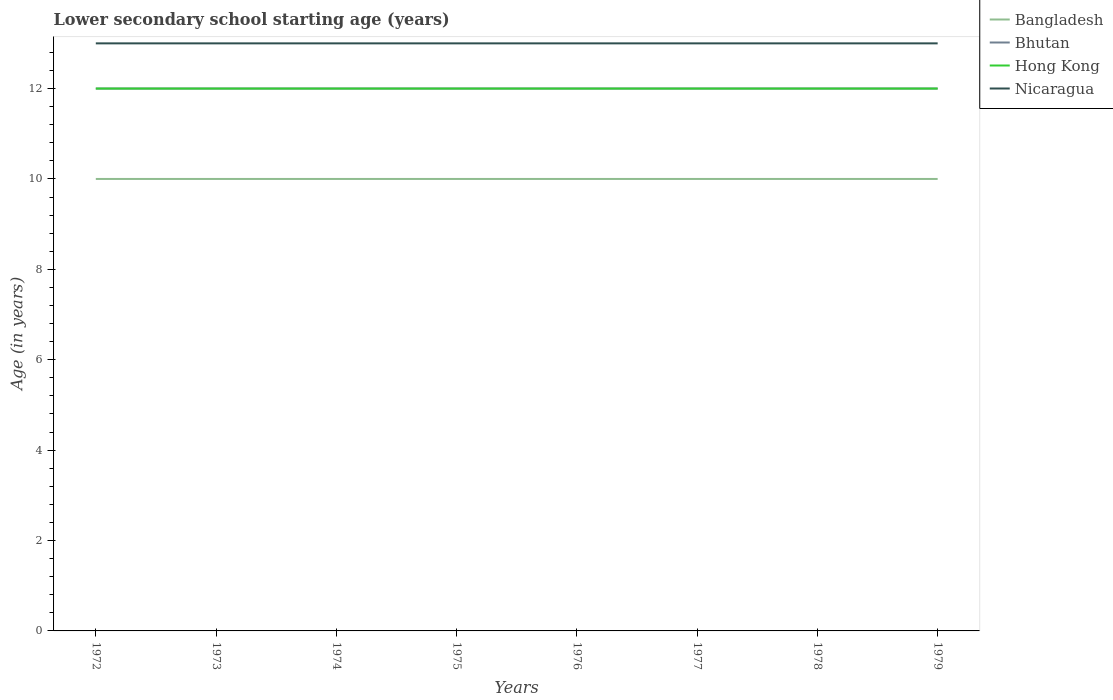How many different coloured lines are there?
Offer a terse response. 4. Across all years, what is the maximum lower secondary school starting age of children in Bhutan?
Keep it short and to the point. 12. What is the difference between the highest and the second highest lower secondary school starting age of children in Bangladesh?
Make the answer very short. 0. Is the lower secondary school starting age of children in Bhutan strictly greater than the lower secondary school starting age of children in Nicaragua over the years?
Offer a very short reply. Yes. How many lines are there?
Make the answer very short. 4. What is the difference between two consecutive major ticks on the Y-axis?
Ensure brevity in your answer.  2. Are the values on the major ticks of Y-axis written in scientific E-notation?
Provide a short and direct response. No. Does the graph contain grids?
Keep it short and to the point. No. Where does the legend appear in the graph?
Offer a very short reply. Top right. How many legend labels are there?
Offer a terse response. 4. What is the title of the graph?
Your answer should be very brief. Lower secondary school starting age (years). What is the label or title of the X-axis?
Offer a terse response. Years. What is the label or title of the Y-axis?
Your answer should be very brief. Age (in years). What is the Age (in years) in Bangladesh in 1972?
Your answer should be compact. 10. What is the Age (in years) of Bhutan in 1972?
Make the answer very short. 12. What is the Age (in years) in Hong Kong in 1972?
Provide a succinct answer. 12. What is the Age (in years) of Nicaragua in 1972?
Your response must be concise. 13. What is the Age (in years) in Bangladesh in 1973?
Your response must be concise. 10. What is the Age (in years) in Bhutan in 1973?
Make the answer very short. 12. What is the Age (in years) of Nicaragua in 1973?
Your answer should be compact. 13. What is the Age (in years) in Bangladesh in 1975?
Your answer should be compact. 10. What is the Age (in years) of Bangladesh in 1976?
Your response must be concise. 10. What is the Age (in years) of Bhutan in 1976?
Give a very brief answer. 12. What is the Age (in years) in Nicaragua in 1976?
Ensure brevity in your answer.  13. What is the Age (in years) in Hong Kong in 1977?
Your response must be concise. 12. What is the Age (in years) of Bangladesh in 1978?
Make the answer very short. 10. What is the Age (in years) of Bhutan in 1978?
Ensure brevity in your answer.  12. What is the Age (in years) of Hong Kong in 1978?
Give a very brief answer. 12. What is the Age (in years) of Bangladesh in 1979?
Keep it short and to the point. 10. What is the Age (in years) of Bhutan in 1979?
Offer a very short reply. 12. Across all years, what is the maximum Age (in years) of Bhutan?
Ensure brevity in your answer.  12. Across all years, what is the minimum Age (in years) of Bangladesh?
Your response must be concise. 10. Across all years, what is the minimum Age (in years) in Hong Kong?
Make the answer very short. 12. What is the total Age (in years) in Bangladesh in the graph?
Your answer should be compact. 80. What is the total Age (in years) in Bhutan in the graph?
Ensure brevity in your answer.  96. What is the total Age (in years) of Hong Kong in the graph?
Provide a succinct answer. 96. What is the total Age (in years) of Nicaragua in the graph?
Keep it short and to the point. 104. What is the difference between the Age (in years) in Bangladesh in 1972 and that in 1973?
Your response must be concise. 0. What is the difference between the Age (in years) in Bhutan in 1972 and that in 1973?
Offer a terse response. 0. What is the difference between the Age (in years) in Bangladesh in 1972 and that in 1974?
Keep it short and to the point. 0. What is the difference between the Age (in years) of Nicaragua in 1972 and that in 1974?
Provide a succinct answer. 0. What is the difference between the Age (in years) of Bangladesh in 1972 and that in 1975?
Keep it short and to the point. 0. What is the difference between the Age (in years) in Hong Kong in 1972 and that in 1975?
Make the answer very short. 0. What is the difference between the Age (in years) in Nicaragua in 1972 and that in 1975?
Keep it short and to the point. 0. What is the difference between the Age (in years) in Bangladesh in 1972 and that in 1976?
Make the answer very short. 0. What is the difference between the Age (in years) of Bhutan in 1972 and that in 1976?
Give a very brief answer. 0. What is the difference between the Age (in years) in Nicaragua in 1972 and that in 1976?
Provide a succinct answer. 0. What is the difference between the Age (in years) of Hong Kong in 1972 and that in 1977?
Offer a very short reply. 0. What is the difference between the Age (in years) of Nicaragua in 1972 and that in 1977?
Your answer should be very brief. 0. What is the difference between the Age (in years) in Bangladesh in 1972 and that in 1978?
Offer a very short reply. 0. What is the difference between the Age (in years) in Bhutan in 1972 and that in 1978?
Your response must be concise. 0. What is the difference between the Age (in years) of Hong Kong in 1972 and that in 1978?
Your answer should be compact. 0. What is the difference between the Age (in years) in Nicaragua in 1972 and that in 1978?
Your response must be concise. 0. What is the difference between the Age (in years) of Hong Kong in 1972 and that in 1979?
Your response must be concise. 0. What is the difference between the Age (in years) in Nicaragua in 1972 and that in 1979?
Keep it short and to the point. 0. What is the difference between the Age (in years) of Bhutan in 1973 and that in 1974?
Offer a very short reply. 0. What is the difference between the Age (in years) in Hong Kong in 1973 and that in 1974?
Your answer should be very brief. 0. What is the difference between the Age (in years) of Bhutan in 1973 and that in 1975?
Make the answer very short. 0. What is the difference between the Age (in years) in Bhutan in 1973 and that in 1976?
Offer a very short reply. 0. What is the difference between the Age (in years) of Hong Kong in 1973 and that in 1976?
Keep it short and to the point. 0. What is the difference between the Age (in years) in Nicaragua in 1973 and that in 1976?
Your response must be concise. 0. What is the difference between the Age (in years) of Bhutan in 1973 and that in 1977?
Provide a short and direct response. 0. What is the difference between the Age (in years) of Hong Kong in 1973 and that in 1977?
Offer a terse response. 0. What is the difference between the Age (in years) of Nicaragua in 1973 and that in 1977?
Offer a very short reply. 0. What is the difference between the Age (in years) of Nicaragua in 1973 and that in 1978?
Your response must be concise. 0. What is the difference between the Age (in years) of Bangladesh in 1973 and that in 1979?
Make the answer very short. 0. What is the difference between the Age (in years) of Bhutan in 1974 and that in 1975?
Keep it short and to the point. 0. What is the difference between the Age (in years) of Hong Kong in 1974 and that in 1976?
Your answer should be compact. 0. What is the difference between the Age (in years) in Bangladesh in 1974 and that in 1977?
Offer a terse response. 0. What is the difference between the Age (in years) of Bhutan in 1974 and that in 1977?
Your response must be concise. 0. What is the difference between the Age (in years) in Hong Kong in 1974 and that in 1977?
Give a very brief answer. 0. What is the difference between the Age (in years) of Bangladesh in 1974 and that in 1978?
Your response must be concise. 0. What is the difference between the Age (in years) of Bhutan in 1974 and that in 1978?
Offer a very short reply. 0. What is the difference between the Age (in years) in Hong Kong in 1974 and that in 1978?
Make the answer very short. 0. What is the difference between the Age (in years) in Bangladesh in 1974 and that in 1979?
Give a very brief answer. 0. What is the difference between the Age (in years) of Bhutan in 1974 and that in 1979?
Offer a terse response. 0. What is the difference between the Age (in years) of Hong Kong in 1974 and that in 1979?
Keep it short and to the point. 0. What is the difference between the Age (in years) of Bangladesh in 1975 and that in 1976?
Your response must be concise. 0. What is the difference between the Age (in years) of Nicaragua in 1975 and that in 1976?
Your response must be concise. 0. What is the difference between the Age (in years) in Bangladesh in 1975 and that in 1977?
Give a very brief answer. 0. What is the difference between the Age (in years) in Bhutan in 1975 and that in 1977?
Provide a succinct answer. 0. What is the difference between the Age (in years) of Hong Kong in 1975 and that in 1977?
Offer a very short reply. 0. What is the difference between the Age (in years) in Nicaragua in 1975 and that in 1977?
Keep it short and to the point. 0. What is the difference between the Age (in years) in Bangladesh in 1975 and that in 1978?
Provide a succinct answer. 0. What is the difference between the Age (in years) in Hong Kong in 1975 and that in 1978?
Give a very brief answer. 0. What is the difference between the Age (in years) of Bangladesh in 1975 and that in 1979?
Give a very brief answer. 0. What is the difference between the Age (in years) of Hong Kong in 1975 and that in 1979?
Your answer should be compact. 0. What is the difference between the Age (in years) in Nicaragua in 1975 and that in 1979?
Your response must be concise. 0. What is the difference between the Age (in years) in Bangladesh in 1976 and that in 1977?
Offer a terse response. 0. What is the difference between the Age (in years) in Bhutan in 1976 and that in 1977?
Ensure brevity in your answer.  0. What is the difference between the Age (in years) in Hong Kong in 1976 and that in 1977?
Provide a succinct answer. 0. What is the difference between the Age (in years) of Bangladesh in 1976 and that in 1978?
Give a very brief answer. 0. What is the difference between the Age (in years) in Bhutan in 1976 and that in 1978?
Your response must be concise. 0. What is the difference between the Age (in years) of Hong Kong in 1976 and that in 1978?
Provide a short and direct response. 0. What is the difference between the Age (in years) of Bangladesh in 1976 and that in 1979?
Make the answer very short. 0. What is the difference between the Age (in years) in Hong Kong in 1976 and that in 1979?
Keep it short and to the point. 0. What is the difference between the Age (in years) of Bhutan in 1977 and that in 1978?
Give a very brief answer. 0. What is the difference between the Age (in years) of Nicaragua in 1977 and that in 1978?
Provide a short and direct response. 0. What is the difference between the Age (in years) of Bangladesh in 1977 and that in 1979?
Make the answer very short. 0. What is the difference between the Age (in years) of Bhutan in 1977 and that in 1979?
Provide a succinct answer. 0. What is the difference between the Age (in years) of Bhutan in 1978 and that in 1979?
Your answer should be very brief. 0. What is the difference between the Age (in years) in Hong Kong in 1978 and that in 1979?
Your answer should be compact. 0. What is the difference between the Age (in years) of Bangladesh in 1972 and the Age (in years) of Bhutan in 1973?
Your answer should be compact. -2. What is the difference between the Age (in years) of Bhutan in 1972 and the Age (in years) of Hong Kong in 1973?
Your answer should be very brief. 0. What is the difference between the Age (in years) in Bhutan in 1972 and the Age (in years) in Nicaragua in 1973?
Give a very brief answer. -1. What is the difference between the Age (in years) in Hong Kong in 1972 and the Age (in years) in Nicaragua in 1973?
Provide a short and direct response. -1. What is the difference between the Age (in years) of Bhutan in 1972 and the Age (in years) of Hong Kong in 1974?
Your answer should be very brief. 0. What is the difference between the Age (in years) of Bhutan in 1972 and the Age (in years) of Nicaragua in 1974?
Keep it short and to the point. -1. What is the difference between the Age (in years) of Hong Kong in 1972 and the Age (in years) of Nicaragua in 1974?
Your answer should be very brief. -1. What is the difference between the Age (in years) in Bangladesh in 1972 and the Age (in years) in Hong Kong in 1975?
Provide a short and direct response. -2. What is the difference between the Age (in years) of Bangladesh in 1972 and the Age (in years) of Nicaragua in 1975?
Make the answer very short. -3. What is the difference between the Age (in years) of Bhutan in 1972 and the Age (in years) of Hong Kong in 1975?
Offer a terse response. 0. What is the difference between the Age (in years) of Hong Kong in 1972 and the Age (in years) of Nicaragua in 1975?
Your answer should be very brief. -1. What is the difference between the Age (in years) in Bangladesh in 1972 and the Age (in years) in Bhutan in 1976?
Ensure brevity in your answer.  -2. What is the difference between the Age (in years) in Bhutan in 1972 and the Age (in years) in Hong Kong in 1976?
Offer a very short reply. 0. What is the difference between the Age (in years) in Bhutan in 1972 and the Age (in years) in Nicaragua in 1976?
Offer a terse response. -1. What is the difference between the Age (in years) in Hong Kong in 1972 and the Age (in years) in Nicaragua in 1976?
Your response must be concise. -1. What is the difference between the Age (in years) of Bangladesh in 1972 and the Age (in years) of Bhutan in 1977?
Provide a succinct answer. -2. What is the difference between the Age (in years) of Bangladesh in 1972 and the Age (in years) of Hong Kong in 1977?
Your answer should be very brief. -2. What is the difference between the Age (in years) of Bangladesh in 1972 and the Age (in years) of Nicaragua in 1977?
Give a very brief answer. -3. What is the difference between the Age (in years) of Bhutan in 1972 and the Age (in years) of Nicaragua in 1977?
Make the answer very short. -1. What is the difference between the Age (in years) in Hong Kong in 1972 and the Age (in years) in Nicaragua in 1977?
Make the answer very short. -1. What is the difference between the Age (in years) of Bangladesh in 1972 and the Age (in years) of Hong Kong in 1978?
Offer a terse response. -2. What is the difference between the Age (in years) of Bhutan in 1972 and the Age (in years) of Nicaragua in 1978?
Provide a succinct answer. -1. What is the difference between the Age (in years) of Bhutan in 1972 and the Age (in years) of Nicaragua in 1979?
Your answer should be compact. -1. What is the difference between the Age (in years) in Hong Kong in 1972 and the Age (in years) in Nicaragua in 1979?
Provide a short and direct response. -1. What is the difference between the Age (in years) in Bangladesh in 1973 and the Age (in years) in Bhutan in 1974?
Your answer should be very brief. -2. What is the difference between the Age (in years) in Bangladesh in 1973 and the Age (in years) in Nicaragua in 1974?
Your answer should be very brief. -3. What is the difference between the Age (in years) of Bangladesh in 1973 and the Age (in years) of Hong Kong in 1975?
Offer a terse response. -2. What is the difference between the Age (in years) of Bangladesh in 1973 and the Age (in years) of Nicaragua in 1975?
Your response must be concise. -3. What is the difference between the Age (in years) in Bangladesh in 1973 and the Age (in years) in Bhutan in 1976?
Offer a very short reply. -2. What is the difference between the Age (in years) in Bhutan in 1973 and the Age (in years) in Nicaragua in 1976?
Keep it short and to the point. -1. What is the difference between the Age (in years) of Hong Kong in 1973 and the Age (in years) of Nicaragua in 1976?
Your answer should be very brief. -1. What is the difference between the Age (in years) of Bangladesh in 1973 and the Age (in years) of Hong Kong in 1977?
Your response must be concise. -2. What is the difference between the Age (in years) of Bangladesh in 1973 and the Age (in years) of Nicaragua in 1977?
Your answer should be compact. -3. What is the difference between the Age (in years) in Bhutan in 1973 and the Age (in years) in Nicaragua in 1977?
Offer a very short reply. -1. What is the difference between the Age (in years) of Hong Kong in 1973 and the Age (in years) of Nicaragua in 1977?
Provide a short and direct response. -1. What is the difference between the Age (in years) in Bangladesh in 1973 and the Age (in years) in Bhutan in 1978?
Ensure brevity in your answer.  -2. What is the difference between the Age (in years) in Bangladesh in 1973 and the Age (in years) in Hong Kong in 1978?
Offer a terse response. -2. What is the difference between the Age (in years) in Bangladesh in 1973 and the Age (in years) in Nicaragua in 1978?
Provide a succinct answer. -3. What is the difference between the Age (in years) of Bhutan in 1973 and the Age (in years) of Nicaragua in 1978?
Provide a short and direct response. -1. What is the difference between the Age (in years) of Bangladesh in 1973 and the Age (in years) of Hong Kong in 1979?
Keep it short and to the point. -2. What is the difference between the Age (in years) of Bhutan in 1973 and the Age (in years) of Nicaragua in 1979?
Make the answer very short. -1. What is the difference between the Age (in years) in Hong Kong in 1973 and the Age (in years) in Nicaragua in 1979?
Keep it short and to the point. -1. What is the difference between the Age (in years) in Bangladesh in 1974 and the Age (in years) in Bhutan in 1975?
Your answer should be very brief. -2. What is the difference between the Age (in years) in Bhutan in 1974 and the Age (in years) in Nicaragua in 1975?
Your response must be concise. -1. What is the difference between the Age (in years) of Bangladesh in 1974 and the Age (in years) of Bhutan in 1976?
Offer a very short reply. -2. What is the difference between the Age (in years) in Bangladesh in 1974 and the Age (in years) in Nicaragua in 1976?
Ensure brevity in your answer.  -3. What is the difference between the Age (in years) in Bhutan in 1974 and the Age (in years) in Hong Kong in 1976?
Offer a very short reply. 0. What is the difference between the Age (in years) in Bhutan in 1974 and the Age (in years) in Nicaragua in 1976?
Your response must be concise. -1. What is the difference between the Age (in years) in Bangladesh in 1974 and the Age (in years) in Bhutan in 1977?
Offer a very short reply. -2. What is the difference between the Age (in years) of Bangladesh in 1974 and the Age (in years) of Hong Kong in 1977?
Your answer should be compact. -2. What is the difference between the Age (in years) in Bhutan in 1974 and the Age (in years) in Hong Kong in 1977?
Provide a succinct answer. 0. What is the difference between the Age (in years) in Bhutan in 1974 and the Age (in years) in Nicaragua in 1977?
Your answer should be compact. -1. What is the difference between the Age (in years) in Hong Kong in 1974 and the Age (in years) in Nicaragua in 1977?
Offer a very short reply. -1. What is the difference between the Age (in years) in Bangladesh in 1974 and the Age (in years) in Hong Kong in 1978?
Give a very brief answer. -2. What is the difference between the Age (in years) in Bhutan in 1974 and the Age (in years) in Nicaragua in 1978?
Your answer should be compact. -1. What is the difference between the Age (in years) of Hong Kong in 1974 and the Age (in years) of Nicaragua in 1978?
Provide a succinct answer. -1. What is the difference between the Age (in years) in Bangladesh in 1974 and the Age (in years) in Hong Kong in 1979?
Your response must be concise. -2. What is the difference between the Age (in years) in Bangladesh in 1974 and the Age (in years) in Nicaragua in 1979?
Your answer should be compact. -3. What is the difference between the Age (in years) of Bhutan in 1974 and the Age (in years) of Nicaragua in 1979?
Give a very brief answer. -1. What is the difference between the Age (in years) in Hong Kong in 1974 and the Age (in years) in Nicaragua in 1979?
Offer a very short reply. -1. What is the difference between the Age (in years) in Bhutan in 1975 and the Age (in years) in Hong Kong in 1976?
Give a very brief answer. 0. What is the difference between the Age (in years) in Bangladesh in 1975 and the Age (in years) in Bhutan in 1977?
Offer a very short reply. -2. What is the difference between the Age (in years) in Bangladesh in 1975 and the Age (in years) in Nicaragua in 1977?
Keep it short and to the point. -3. What is the difference between the Age (in years) in Bhutan in 1975 and the Age (in years) in Hong Kong in 1977?
Give a very brief answer. 0. What is the difference between the Age (in years) in Hong Kong in 1975 and the Age (in years) in Nicaragua in 1978?
Offer a very short reply. -1. What is the difference between the Age (in years) in Bangladesh in 1975 and the Age (in years) in Bhutan in 1979?
Your response must be concise. -2. What is the difference between the Age (in years) in Bhutan in 1975 and the Age (in years) in Hong Kong in 1979?
Offer a very short reply. 0. What is the difference between the Age (in years) in Bhutan in 1975 and the Age (in years) in Nicaragua in 1979?
Ensure brevity in your answer.  -1. What is the difference between the Age (in years) of Hong Kong in 1975 and the Age (in years) of Nicaragua in 1979?
Ensure brevity in your answer.  -1. What is the difference between the Age (in years) in Bangladesh in 1976 and the Age (in years) in Bhutan in 1977?
Give a very brief answer. -2. What is the difference between the Age (in years) of Bangladesh in 1976 and the Age (in years) of Hong Kong in 1977?
Provide a short and direct response. -2. What is the difference between the Age (in years) of Bangladesh in 1976 and the Age (in years) of Nicaragua in 1977?
Your answer should be very brief. -3. What is the difference between the Age (in years) in Bangladesh in 1976 and the Age (in years) in Bhutan in 1978?
Keep it short and to the point. -2. What is the difference between the Age (in years) in Bangladesh in 1976 and the Age (in years) in Hong Kong in 1978?
Offer a very short reply. -2. What is the difference between the Age (in years) in Bangladesh in 1976 and the Age (in years) in Nicaragua in 1978?
Ensure brevity in your answer.  -3. What is the difference between the Age (in years) in Bhutan in 1976 and the Age (in years) in Hong Kong in 1978?
Your answer should be compact. 0. What is the difference between the Age (in years) in Bhutan in 1976 and the Age (in years) in Nicaragua in 1978?
Your response must be concise. -1. What is the difference between the Age (in years) of Bangladesh in 1976 and the Age (in years) of Nicaragua in 1979?
Provide a short and direct response. -3. What is the difference between the Age (in years) in Bangladesh in 1977 and the Age (in years) in Hong Kong in 1978?
Provide a succinct answer. -2. What is the difference between the Age (in years) in Bhutan in 1977 and the Age (in years) in Hong Kong in 1978?
Ensure brevity in your answer.  0. What is the difference between the Age (in years) in Hong Kong in 1977 and the Age (in years) in Nicaragua in 1978?
Offer a very short reply. -1. What is the difference between the Age (in years) of Bangladesh in 1977 and the Age (in years) of Nicaragua in 1979?
Keep it short and to the point. -3. What is the difference between the Age (in years) in Bhutan in 1977 and the Age (in years) in Hong Kong in 1979?
Give a very brief answer. 0. What is the difference between the Age (in years) in Bhutan in 1977 and the Age (in years) in Nicaragua in 1979?
Offer a very short reply. -1. What is the difference between the Age (in years) of Bangladesh in 1978 and the Age (in years) of Bhutan in 1979?
Give a very brief answer. -2. What is the difference between the Age (in years) of Bangladesh in 1978 and the Age (in years) of Nicaragua in 1979?
Provide a succinct answer. -3. What is the difference between the Age (in years) of Bhutan in 1978 and the Age (in years) of Hong Kong in 1979?
Keep it short and to the point. 0. What is the difference between the Age (in years) of Bhutan in 1978 and the Age (in years) of Nicaragua in 1979?
Ensure brevity in your answer.  -1. What is the difference between the Age (in years) of Hong Kong in 1978 and the Age (in years) of Nicaragua in 1979?
Keep it short and to the point. -1. What is the average Age (in years) in Bangladesh per year?
Keep it short and to the point. 10. What is the average Age (in years) of Bhutan per year?
Ensure brevity in your answer.  12. In the year 1972, what is the difference between the Age (in years) of Bangladesh and Age (in years) of Bhutan?
Ensure brevity in your answer.  -2. In the year 1973, what is the difference between the Age (in years) in Bangladesh and Age (in years) in Nicaragua?
Provide a short and direct response. -3. In the year 1973, what is the difference between the Age (in years) in Bhutan and Age (in years) in Nicaragua?
Offer a very short reply. -1. In the year 1974, what is the difference between the Age (in years) in Bangladesh and Age (in years) in Bhutan?
Ensure brevity in your answer.  -2. In the year 1974, what is the difference between the Age (in years) in Bangladesh and Age (in years) in Nicaragua?
Keep it short and to the point. -3. In the year 1974, what is the difference between the Age (in years) of Bhutan and Age (in years) of Hong Kong?
Keep it short and to the point. 0. In the year 1974, what is the difference between the Age (in years) of Bhutan and Age (in years) of Nicaragua?
Your answer should be compact. -1. In the year 1974, what is the difference between the Age (in years) in Hong Kong and Age (in years) in Nicaragua?
Ensure brevity in your answer.  -1. In the year 1975, what is the difference between the Age (in years) in Bangladesh and Age (in years) in Nicaragua?
Give a very brief answer. -3. In the year 1975, what is the difference between the Age (in years) in Bhutan and Age (in years) in Nicaragua?
Offer a terse response. -1. In the year 1976, what is the difference between the Age (in years) of Bhutan and Age (in years) of Hong Kong?
Offer a very short reply. 0. In the year 1976, what is the difference between the Age (in years) of Hong Kong and Age (in years) of Nicaragua?
Make the answer very short. -1. In the year 1977, what is the difference between the Age (in years) of Bangladesh and Age (in years) of Bhutan?
Your answer should be very brief. -2. In the year 1977, what is the difference between the Age (in years) in Bhutan and Age (in years) in Hong Kong?
Your response must be concise. 0. In the year 1977, what is the difference between the Age (in years) in Bhutan and Age (in years) in Nicaragua?
Give a very brief answer. -1. In the year 1977, what is the difference between the Age (in years) of Hong Kong and Age (in years) of Nicaragua?
Your answer should be compact. -1. In the year 1978, what is the difference between the Age (in years) in Bangladesh and Age (in years) in Hong Kong?
Provide a short and direct response. -2. In the year 1978, what is the difference between the Age (in years) in Bhutan and Age (in years) in Hong Kong?
Provide a short and direct response. 0. In the year 1978, what is the difference between the Age (in years) in Bhutan and Age (in years) in Nicaragua?
Offer a very short reply. -1. In the year 1978, what is the difference between the Age (in years) of Hong Kong and Age (in years) of Nicaragua?
Give a very brief answer. -1. In the year 1979, what is the difference between the Age (in years) of Bhutan and Age (in years) of Hong Kong?
Your response must be concise. 0. In the year 1979, what is the difference between the Age (in years) of Bhutan and Age (in years) of Nicaragua?
Provide a short and direct response. -1. In the year 1979, what is the difference between the Age (in years) in Hong Kong and Age (in years) in Nicaragua?
Provide a succinct answer. -1. What is the ratio of the Age (in years) of Bangladesh in 1972 to that in 1973?
Provide a short and direct response. 1. What is the ratio of the Age (in years) in Hong Kong in 1972 to that in 1974?
Make the answer very short. 1. What is the ratio of the Age (in years) in Nicaragua in 1972 to that in 1975?
Offer a terse response. 1. What is the ratio of the Age (in years) in Hong Kong in 1972 to that in 1976?
Your answer should be very brief. 1. What is the ratio of the Age (in years) in Bhutan in 1972 to that in 1977?
Offer a terse response. 1. What is the ratio of the Age (in years) of Hong Kong in 1972 to that in 1977?
Your answer should be very brief. 1. What is the ratio of the Age (in years) in Bhutan in 1972 to that in 1978?
Offer a terse response. 1. What is the ratio of the Age (in years) in Hong Kong in 1972 to that in 1978?
Make the answer very short. 1. What is the ratio of the Age (in years) of Nicaragua in 1972 to that in 1978?
Ensure brevity in your answer.  1. What is the ratio of the Age (in years) of Bangladesh in 1972 to that in 1979?
Your answer should be compact. 1. What is the ratio of the Age (in years) in Hong Kong in 1972 to that in 1979?
Offer a terse response. 1. What is the ratio of the Age (in years) of Nicaragua in 1972 to that in 1979?
Offer a terse response. 1. What is the ratio of the Age (in years) of Bangladesh in 1973 to that in 1974?
Offer a terse response. 1. What is the ratio of the Age (in years) in Bhutan in 1973 to that in 1974?
Give a very brief answer. 1. What is the ratio of the Age (in years) of Nicaragua in 1973 to that in 1974?
Ensure brevity in your answer.  1. What is the ratio of the Age (in years) of Bhutan in 1973 to that in 1975?
Make the answer very short. 1. What is the ratio of the Age (in years) of Bangladesh in 1973 to that in 1976?
Make the answer very short. 1. What is the ratio of the Age (in years) of Nicaragua in 1973 to that in 1976?
Ensure brevity in your answer.  1. What is the ratio of the Age (in years) in Hong Kong in 1973 to that in 1977?
Offer a very short reply. 1. What is the ratio of the Age (in years) of Hong Kong in 1973 to that in 1978?
Provide a short and direct response. 1. What is the ratio of the Age (in years) of Nicaragua in 1973 to that in 1978?
Keep it short and to the point. 1. What is the ratio of the Age (in years) in Bhutan in 1973 to that in 1979?
Keep it short and to the point. 1. What is the ratio of the Age (in years) in Nicaragua in 1973 to that in 1979?
Offer a very short reply. 1. What is the ratio of the Age (in years) in Hong Kong in 1974 to that in 1975?
Your answer should be compact. 1. What is the ratio of the Age (in years) in Nicaragua in 1974 to that in 1975?
Offer a terse response. 1. What is the ratio of the Age (in years) in Bangladesh in 1974 to that in 1976?
Provide a succinct answer. 1. What is the ratio of the Age (in years) of Hong Kong in 1974 to that in 1976?
Provide a succinct answer. 1. What is the ratio of the Age (in years) in Nicaragua in 1974 to that in 1976?
Make the answer very short. 1. What is the ratio of the Age (in years) of Hong Kong in 1974 to that in 1977?
Your answer should be compact. 1. What is the ratio of the Age (in years) of Bangladesh in 1974 to that in 1978?
Keep it short and to the point. 1. What is the ratio of the Age (in years) in Hong Kong in 1974 to that in 1978?
Provide a short and direct response. 1. What is the ratio of the Age (in years) of Nicaragua in 1974 to that in 1978?
Keep it short and to the point. 1. What is the ratio of the Age (in years) in Bhutan in 1974 to that in 1979?
Ensure brevity in your answer.  1. What is the ratio of the Age (in years) of Nicaragua in 1974 to that in 1979?
Keep it short and to the point. 1. What is the ratio of the Age (in years) of Bhutan in 1975 to that in 1977?
Provide a short and direct response. 1. What is the ratio of the Age (in years) in Nicaragua in 1975 to that in 1977?
Make the answer very short. 1. What is the ratio of the Age (in years) in Bangladesh in 1975 to that in 1978?
Provide a succinct answer. 1. What is the ratio of the Age (in years) in Bhutan in 1975 to that in 1978?
Offer a terse response. 1. What is the ratio of the Age (in years) in Bhutan in 1976 to that in 1977?
Ensure brevity in your answer.  1. What is the ratio of the Age (in years) of Hong Kong in 1976 to that in 1977?
Ensure brevity in your answer.  1. What is the ratio of the Age (in years) of Nicaragua in 1976 to that in 1977?
Your answer should be compact. 1. What is the ratio of the Age (in years) in Hong Kong in 1976 to that in 1978?
Offer a terse response. 1. What is the ratio of the Age (in years) of Bhutan in 1976 to that in 1979?
Ensure brevity in your answer.  1. What is the ratio of the Age (in years) of Nicaragua in 1976 to that in 1979?
Offer a very short reply. 1. What is the ratio of the Age (in years) of Bangladesh in 1977 to that in 1978?
Ensure brevity in your answer.  1. What is the ratio of the Age (in years) of Bhutan in 1977 to that in 1978?
Give a very brief answer. 1. What is the ratio of the Age (in years) of Hong Kong in 1977 to that in 1978?
Provide a succinct answer. 1. What is the ratio of the Age (in years) in Bangladesh in 1977 to that in 1979?
Your answer should be compact. 1. What is the ratio of the Age (in years) of Bhutan in 1977 to that in 1979?
Keep it short and to the point. 1. What is the ratio of the Age (in years) in Nicaragua in 1977 to that in 1979?
Your response must be concise. 1. What is the ratio of the Age (in years) in Bangladesh in 1978 to that in 1979?
Your answer should be compact. 1. What is the ratio of the Age (in years) of Nicaragua in 1978 to that in 1979?
Offer a terse response. 1. What is the difference between the highest and the second highest Age (in years) of Hong Kong?
Give a very brief answer. 0. What is the difference between the highest and the lowest Age (in years) in Bhutan?
Your response must be concise. 0. What is the difference between the highest and the lowest Age (in years) in Hong Kong?
Give a very brief answer. 0. 